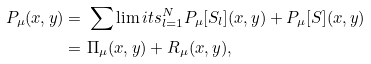Convert formula to latex. <formula><loc_0><loc_0><loc_500><loc_500>P _ { \mu } ( x , y ) = & \ \sum \lim i t s _ { l = 1 } ^ { N } P _ { \mu } [ S _ { l } ] ( x , y ) + P _ { \mu } [ S ] ( x , y ) \\ = & \ \Pi _ { \mu } ( x , y ) + R _ { \mu } ( x , y ) ,</formula> 